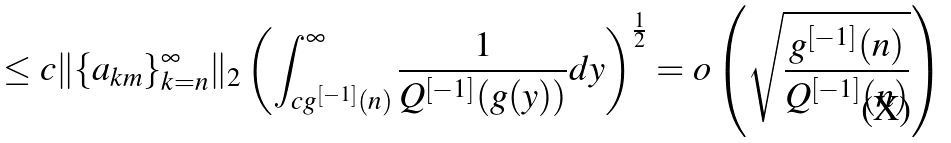<formula> <loc_0><loc_0><loc_500><loc_500>\leq c \| \{ a _ { k m } \} _ { k = n } ^ { \infty } \| _ { 2 } \left ( \int _ { c g ^ { [ - 1 ] } ( n ) } ^ { \infty } \frac { 1 } { Q ^ { [ - 1 ] } ( g ( y ) ) } d y \right ) ^ { \frac { 1 } { 2 } } = o \left ( \sqrt { \frac { g ^ { [ - 1 ] } ( n ) } { Q ^ { [ - 1 ] } ( n ) } } \right )</formula> 